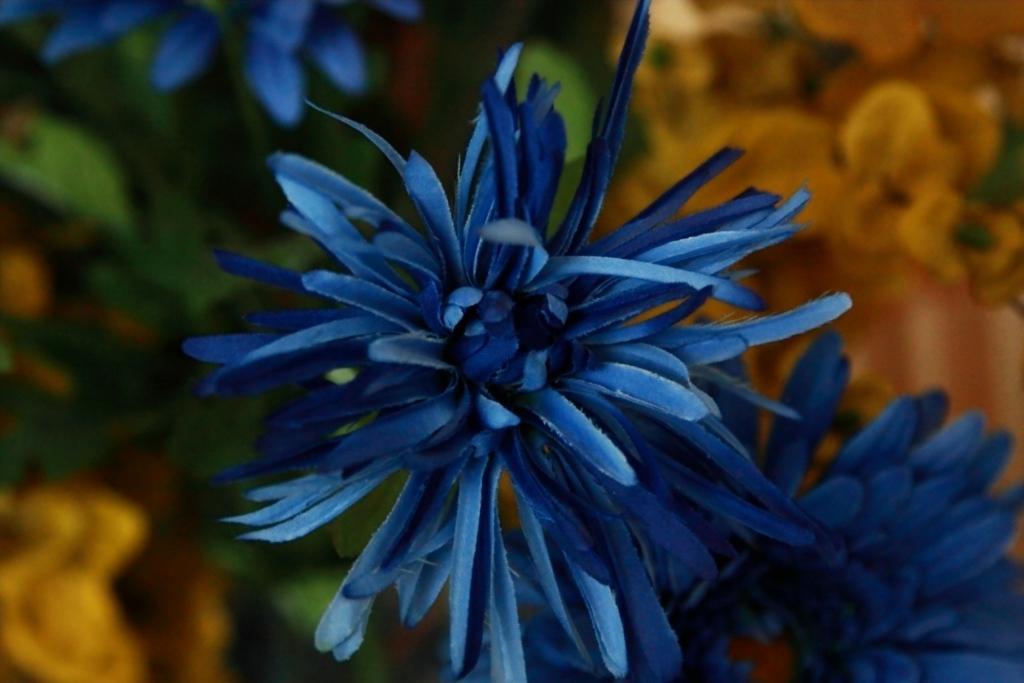Can you describe this image briefly? This image is taken outdoors. In this image the background is a little blurred. In the middle of the image there are a few flowers and green leaves. 